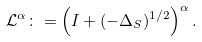Convert formula to latex. <formula><loc_0><loc_0><loc_500><loc_500>\mathcal { L } ^ { \alpha } \colon = \left ( I + ( - \Delta _ { S } ) ^ { 1 / 2 } \right ) ^ { \alpha } .</formula> 